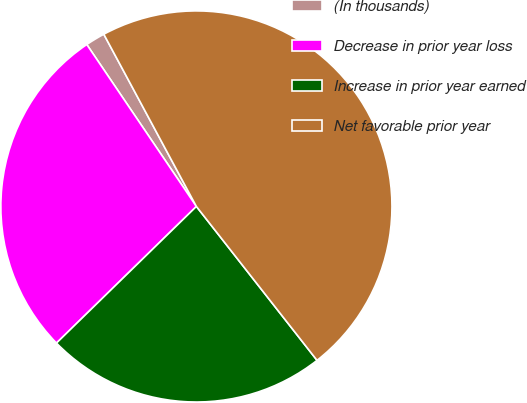Convert chart. <chart><loc_0><loc_0><loc_500><loc_500><pie_chart><fcel>(In thousands)<fcel>Decrease in prior year loss<fcel>Increase in prior year earned<fcel>Net favorable prior year<nl><fcel>1.62%<fcel>27.84%<fcel>23.27%<fcel>47.27%<nl></chart> 